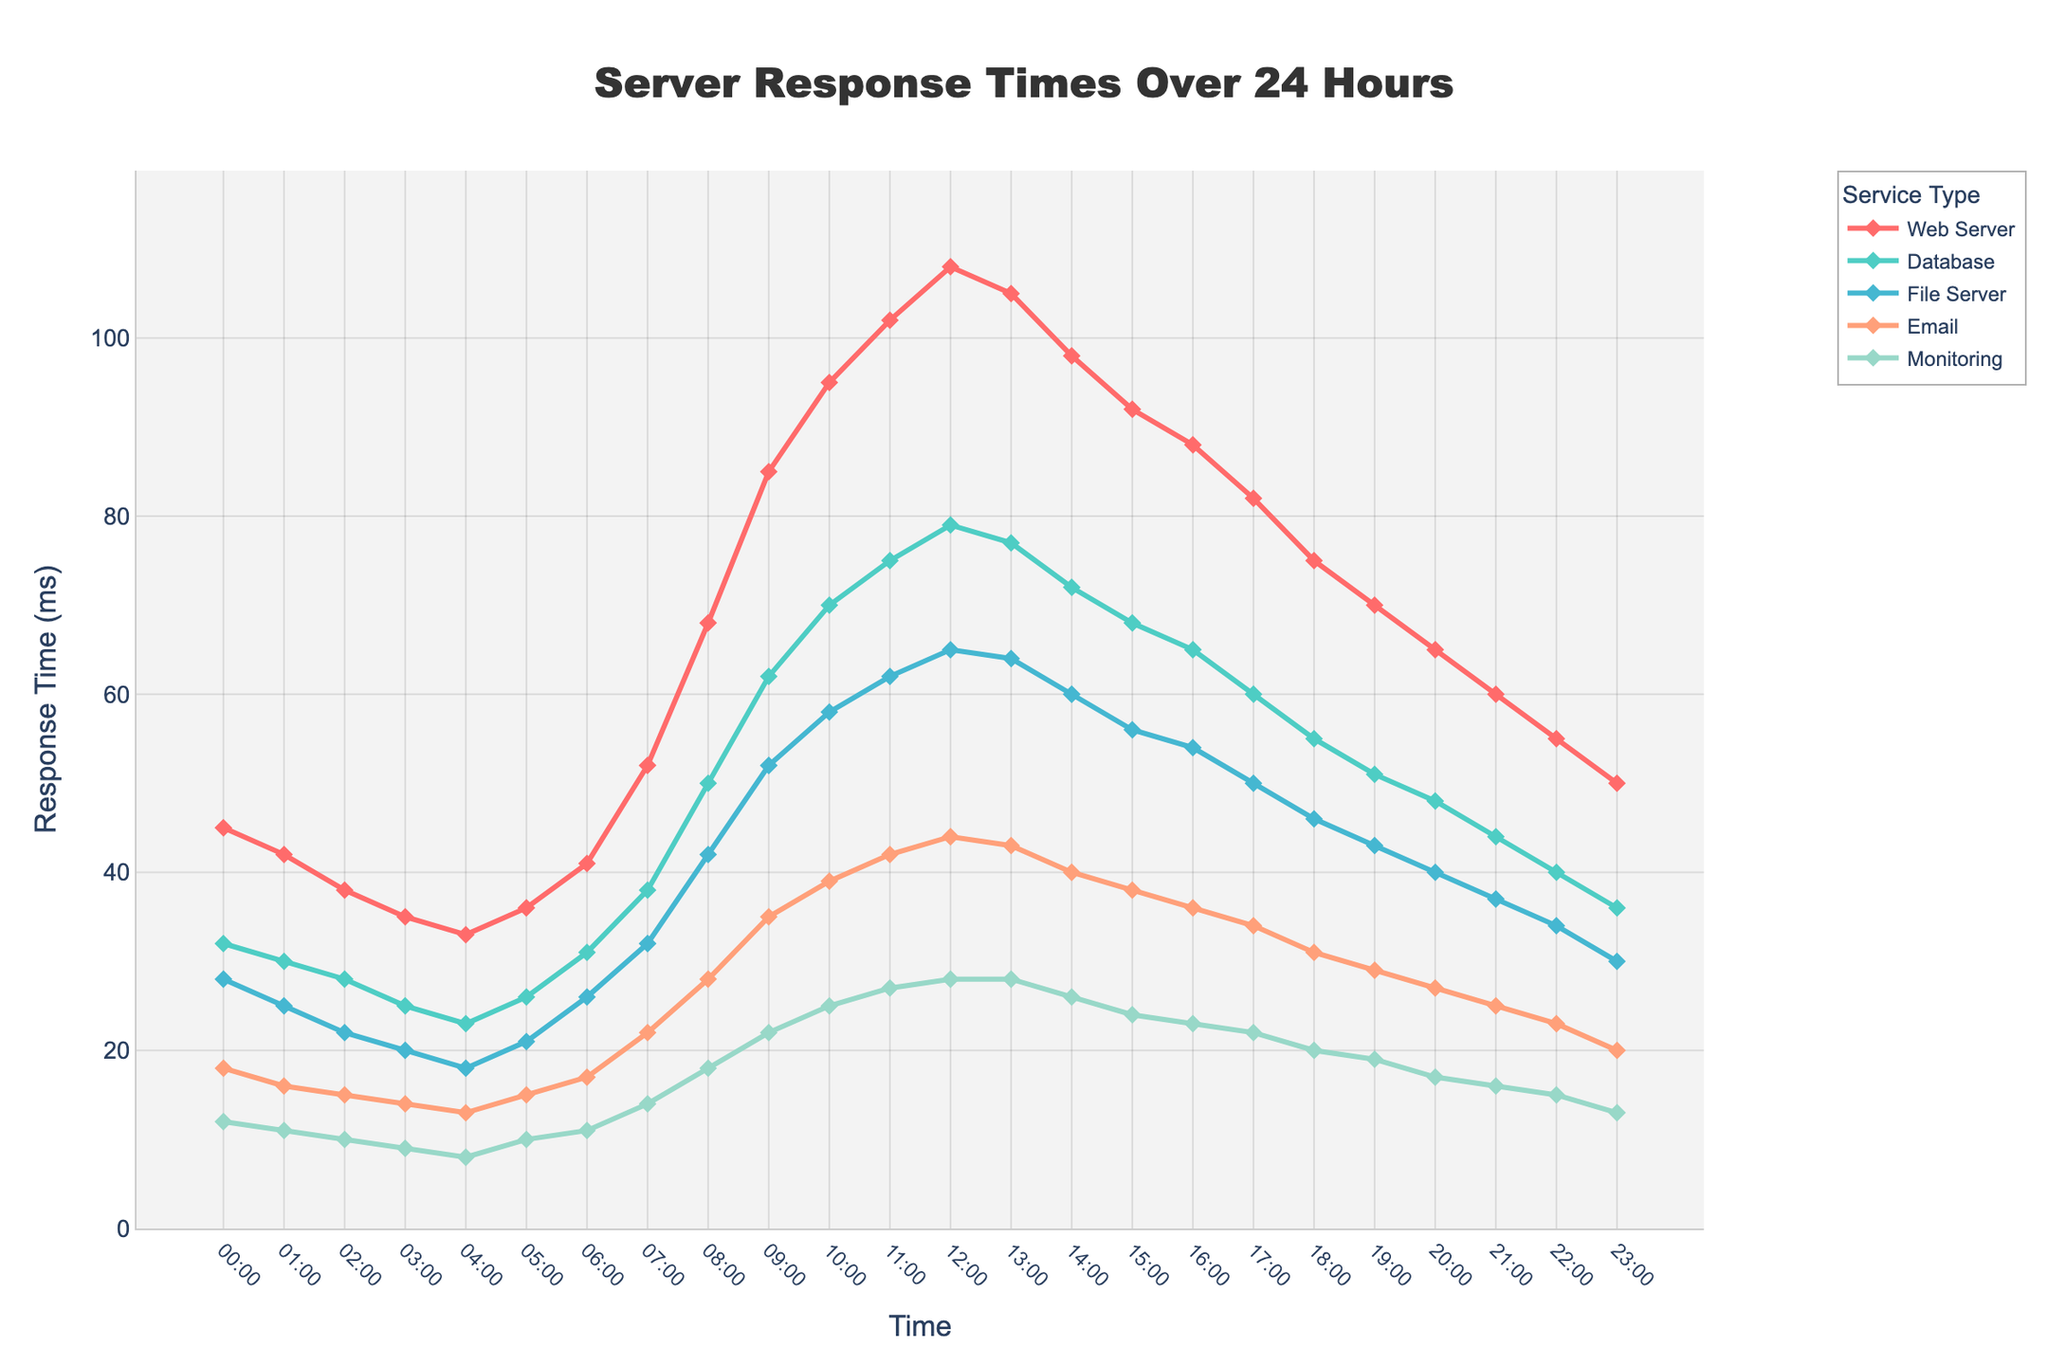What is the response time of the Web Server at 12:00 PM? Locate the point where the 'Web Server' line intersects the 12:00 PM mark on the x-axis. The y-value at this intersection indicates the response time.
Answer: 108 Which server type has the lowest response time at 8:00 AM? Identify the lowest point among the different server lines intersecting the 08:00 mark on the x-axis. The 'Monitoring' line is the lowest.
Answer: Monitoring At what time does the Database server reach its maximum response time? Follow the 'Database' line and locate the peak point along the entire x-axis. The peak point occurs at 12:00 PM.
Answer: 12:00 PM Compare the response time between the Web Server and File Server at 11:00 AM. Which one is higher and by how much? Locate 11:00 AM on the x-axis, then find the intersection points on both the 'Web Server' and 'File Server' lines. Subtract the 'File Server' response time from the 'Web Server' response time.
Answer: Web Server by 40ms What times show the greatest increase in response time for the Email server? By examining the 'Email' line plot, the steepest positive slopes indicate the greatest increase in response time. This occurs from 7:00 AM to 9:00 AM.
Answer: 07:00 AM to 09:00 AM Which times show the highest activity for the Monitoring service? Look at the 'Monitoring' line plot and find the highest peaks along the y-axis, which indicates the activity. The peak is around 12:00 PM.
Answer: 12:00 PM What's the average response time for the File Server between 10:00 AM and 2:00 PM? Sum the response times for the File Server at 10:00 AM, 11:00 AM, 12:00 PM, 1:00 PM, and 2:00 PM, and divide by 5 (56 + 62 + 65 + 64 + 60)/5 = 307/5
Answer: 61.4 Which server appears to have the most consistent response time throughout the 24-hour period? Comparing the variations in the lines, the 'Monitoring' server has the least fluctuation, indicating the most consistent response time.
Answer: Monitoring What is the overall trend for response times for the Web Server? By observing the 'Web Server' line from start to end, it shows an initial increase until around noon, followed by a gradual decrease.
Answer: Increase then decrease 